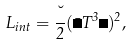<formula> <loc_0><loc_0><loc_500><loc_500>L _ { i n t } = \frac { \lambda } { 2 } ( \bar { \Psi } T ^ { 3 } \Psi ) ^ { 2 } ,</formula> 